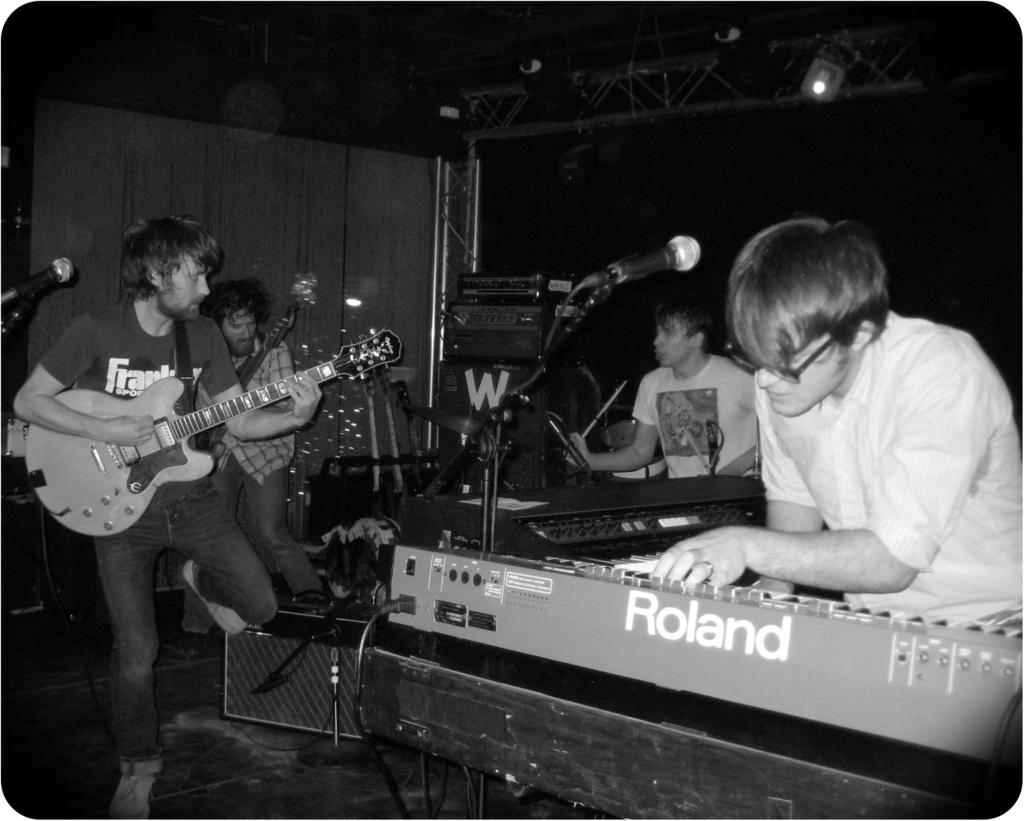<image>
Create a compact narrative representing the image presented. A band is playing in a venue and the keyboardist is using a Roland keyboard. 